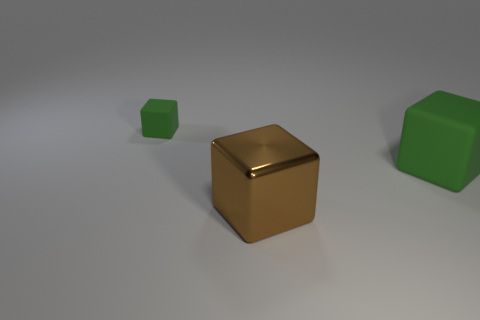Subtract all green cubes. How many cubes are left? 1 Subtract all brown blocks. How many blocks are left? 2 Subtract 1 blocks. How many blocks are left? 2 Add 3 big brown metal objects. How many objects exist? 6 Subtract all red cylinders. How many brown cubes are left? 1 Subtract all big brown blocks. Subtract all big brown objects. How many objects are left? 1 Add 2 large green cubes. How many large green cubes are left? 3 Add 3 large green blocks. How many large green blocks exist? 4 Subtract 0 blue balls. How many objects are left? 3 Subtract all cyan cubes. Subtract all green cylinders. How many cubes are left? 3 